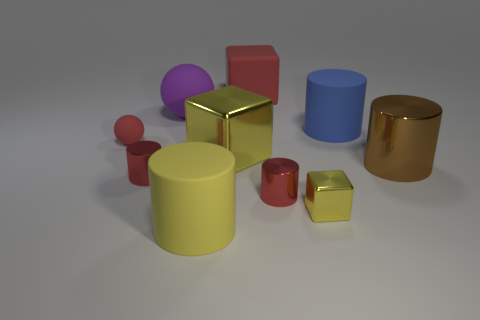Subtract all red cylinders. How many were subtracted if there are1red cylinders left? 1 Subtract all large yellow rubber cylinders. How many cylinders are left? 4 Subtract 3 cubes. How many cubes are left? 0 Subtract all blue balls. How many yellow cubes are left? 2 Subtract all balls. How many objects are left? 8 Subtract all blue cylinders. How many cylinders are left? 4 Add 2 large yellow rubber things. How many large yellow rubber things exist? 3 Subtract 0 green cubes. How many objects are left? 10 Subtract all gray blocks. Subtract all blue cylinders. How many blocks are left? 3 Subtract all large metallic cylinders. Subtract all yellow rubber cylinders. How many objects are left? 8 